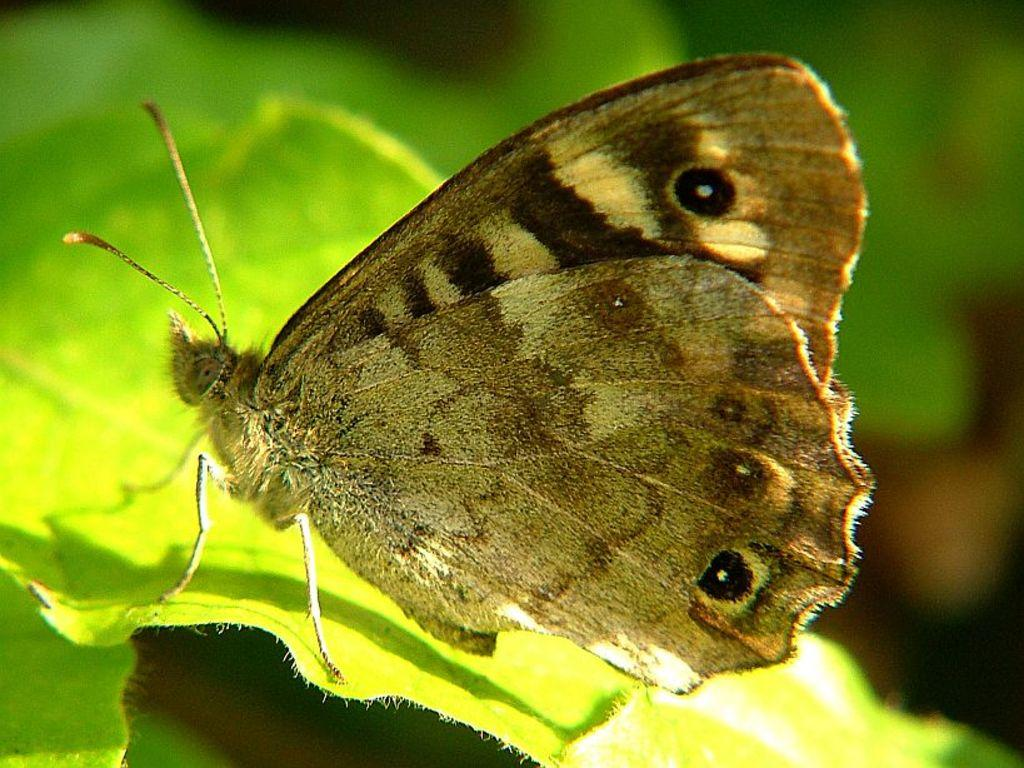What is the main subject of the image? There is a butterfly in the image. Where is the butterfly located? The butterfly is on a leaf. Are there any other leaves visible in the image? Yes, there is another leaf visible in the bottom left of the image. How would you describe the background of the image? The background of the image is blurred. How many pies are being turned by the butterfly in the image? There are no pies or turning actions present in the image; it features a butterfly on a leaf. 